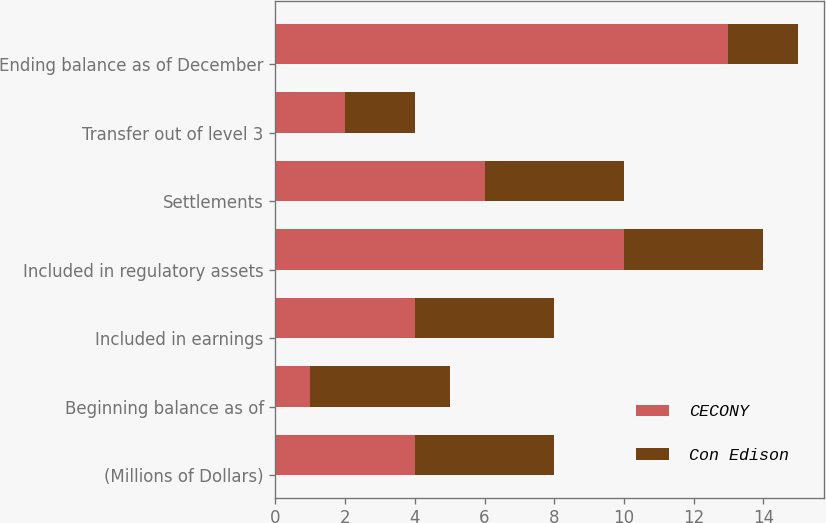<chart> <loc_0><loc_0><loc_500><loc_500><stacked_bar_chart><ecel><fcel>(Millions of Dollars)<fcel>Beginning balance as of<fcel>Included in earnings<fcel>Included in regulatory assets<fcel>Settlements<fcel>Transfer out of level 3<fcel>Ending balance as of December<nl><fcel>CECONY<fcel>4<fcel>1<fcel>4<fcel>10<fcel>6<fcel>2<fcel>13<nl><fcel>Con Edison<fcel>4<fcel>4<fcel>4<fcel>4<fcel>4<fcel>2<fcel>2<nl></chart> 